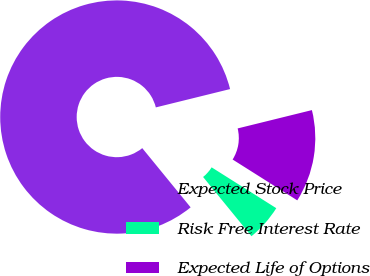Convert chart. <chart><loc_0><loc_0><loc_500><loc_500><pie_chart><fcel>Expected Stock Price<fcel>Risk Free Interest Rate<fcel>Expected Life of Options<nl><fcel>82.05%<fcel>5.13%<fcel>12.82%<nl></chart> 